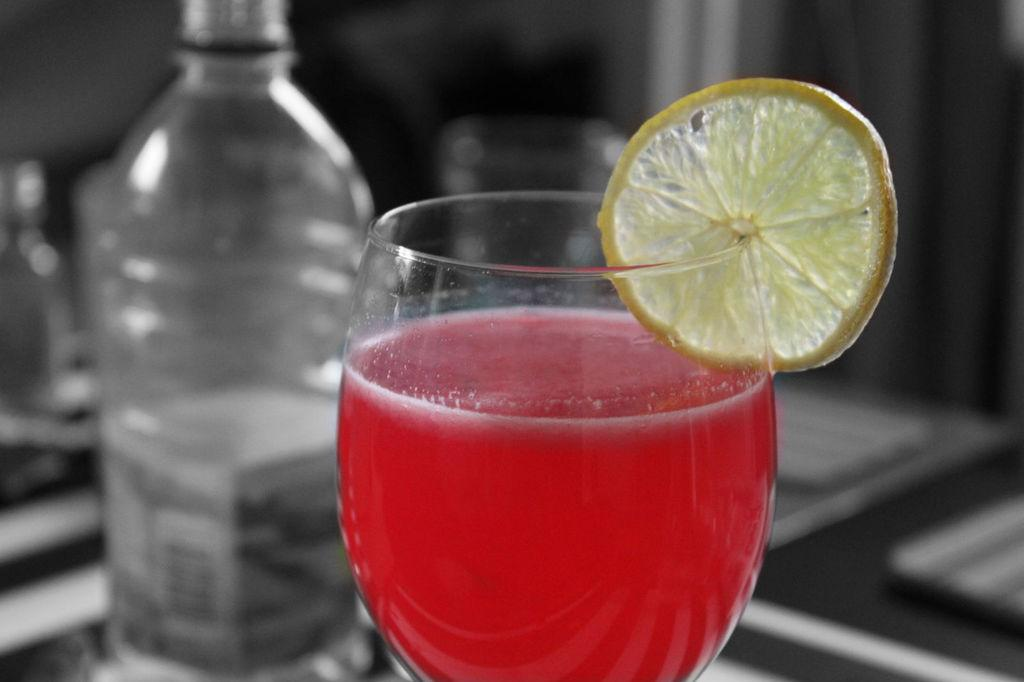What is inside the glass that is visible in the image? There is red-colored water in the glass in the image. What is placed on the glass? There is a piece of lemon on the glass. What can be seen in the background of the image? There is a bottle in the background of the image. How is the bottle depicted in the image? The bottle is blurred in the background. How many children are playing with honey in the image? There are no children or honey present in the image. What type of voice can be heard coming from the bottle in the image? There is no voice coming from the bottle in the image, as it is a blurred object in the background. 